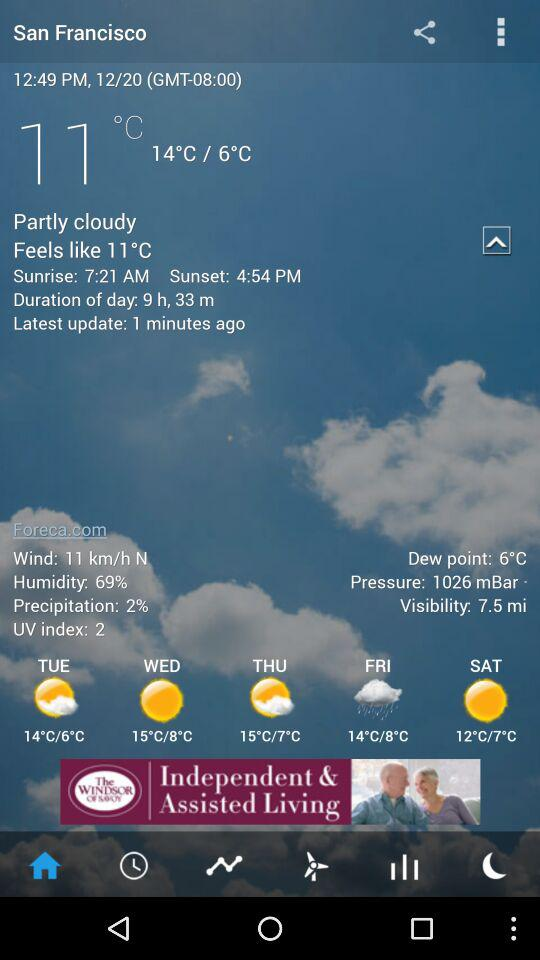Which location is selected? The selected location is San Francisco. 